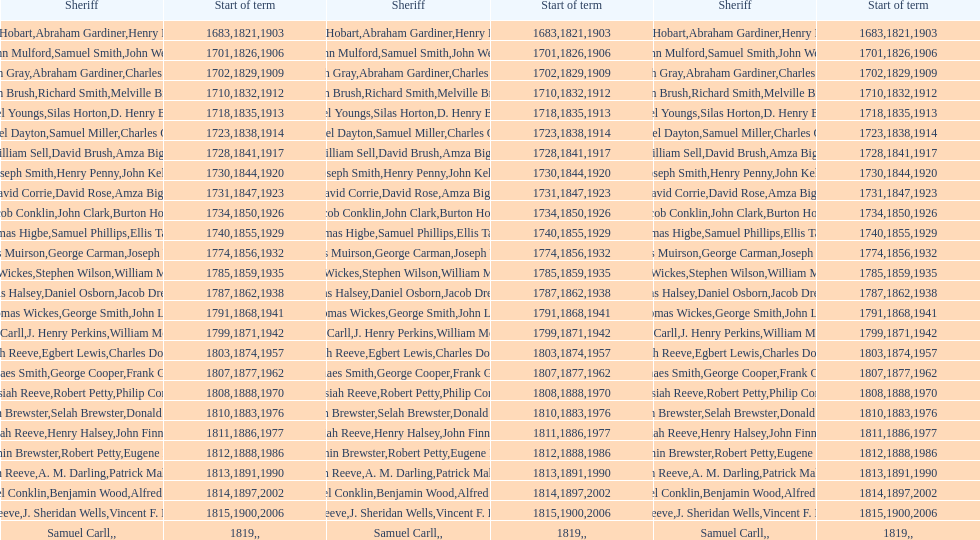When did benjamin brewster serve his second term? 1812. 